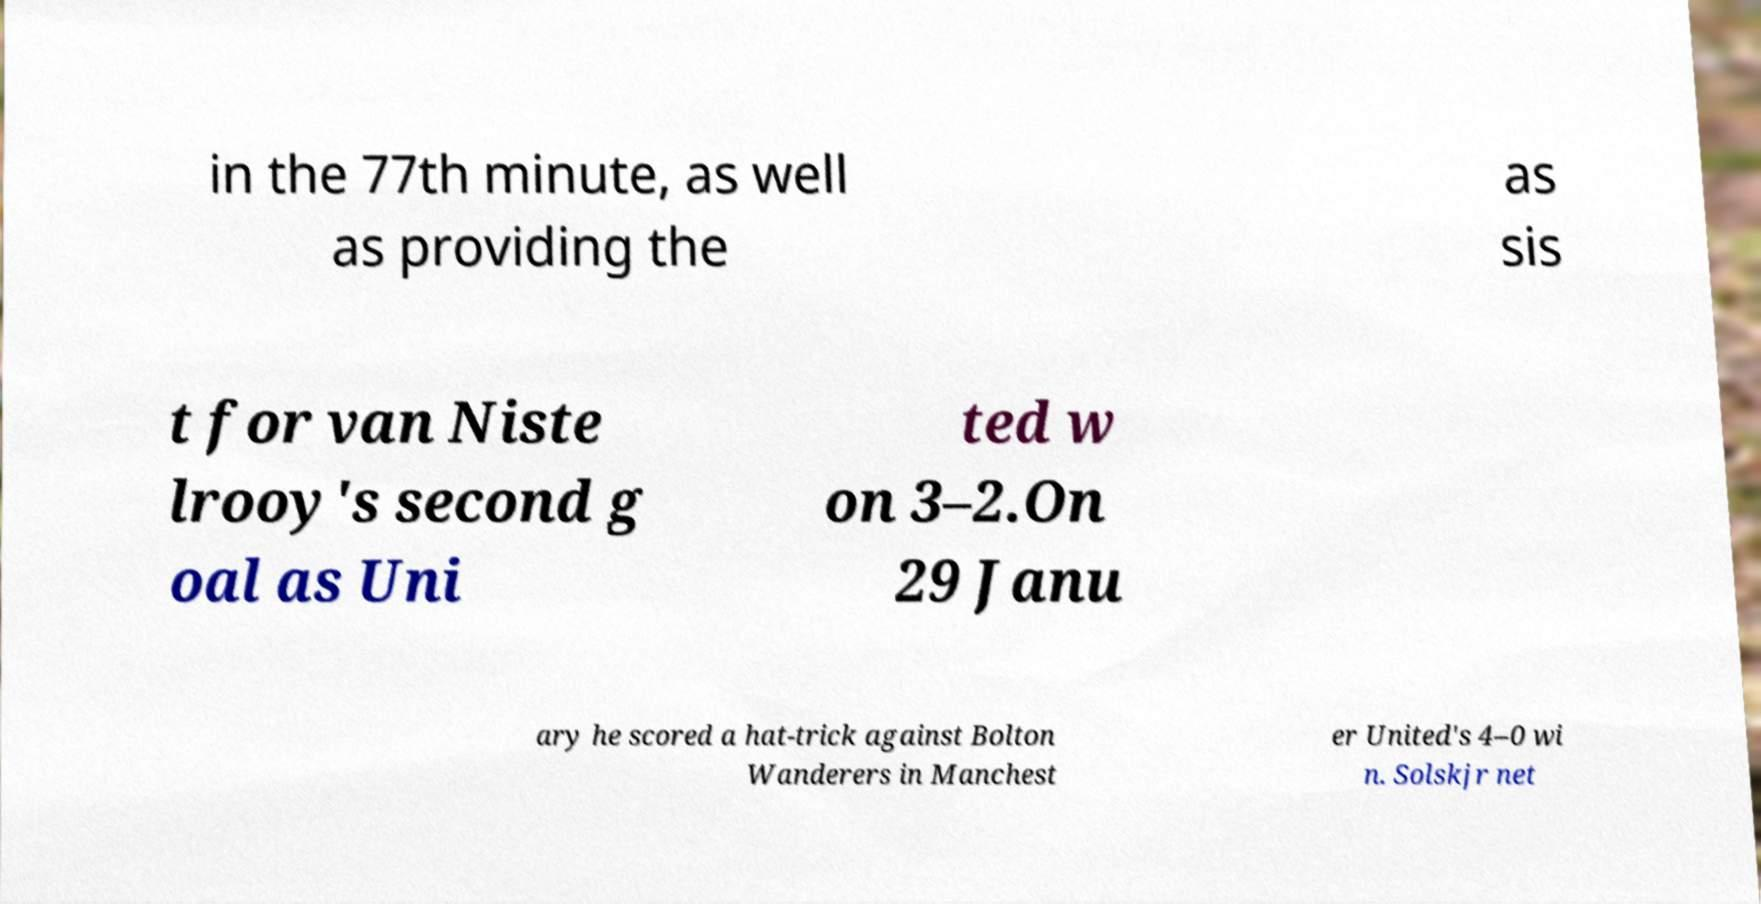What messages or text are displayed in this image? I need them in a readable, typed format. in the 77th minute, as well as providing the as sis t for van Niste lrooy's second g oal as Uni ted w on 3–2.On 29 Janu ary he scored a hat-trick against Bolton Wanderers in Manchest er United's 4–0 wi n. Solskjr net 